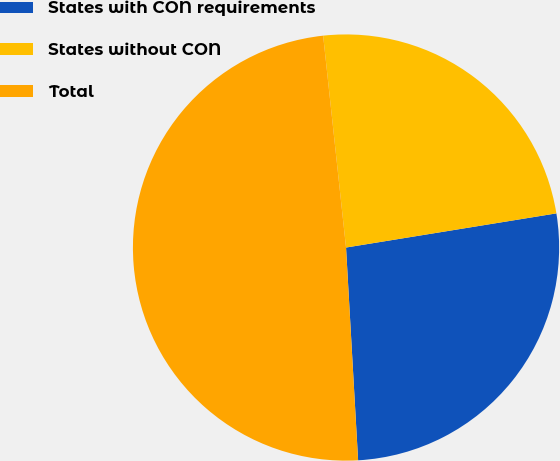Convert chart to OTSL. <chart><loc_0><loc_0><loc_500><loc_500><pie_chart><fcel>States with CON requirements<fcel>States without CON<fcel>Total<nl><fcel>26.66%<fcel>24.15%<fcel>49.19%<nl></chart> 